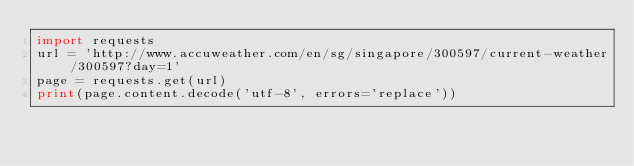<code> <loc_0><loc_0><loc_500><loc_500><_Python_>import requests
url = 'http://www.accuweather.com/en/sg/singapore/300597/current-weather/300597?day=1'
page = requests.get(url)
print(page.content.decode('utf-8', errors='replace'))
</code> 